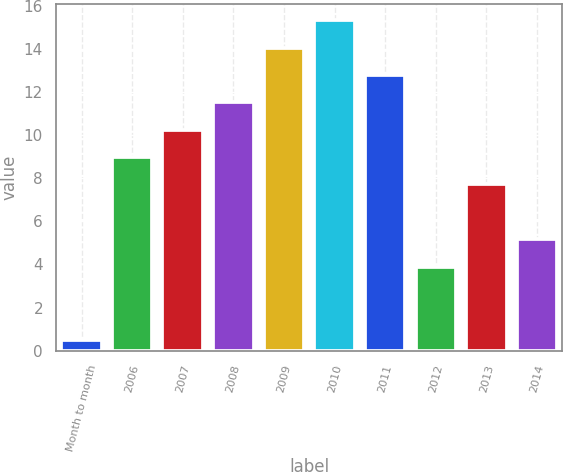Convert chart to OTSL. <chart><loc_0><loc_0><loc_500><loc_500><bar_chart><fcel>Month to month<fcel>2006<fcel>2007<fcel>2008<fcel>2009<fcel>2010<fcel>2011<fcel>2012<fcel>2013<fcel>2014<nl><fcel>0.5<fcel>8.98<fcel>10.25<fcel>11.52<fcel>14.06<fcel>15.33<fcel>12.79<fcel>3.9<fcel>7.71<fcel>5.17<nl></chart> 